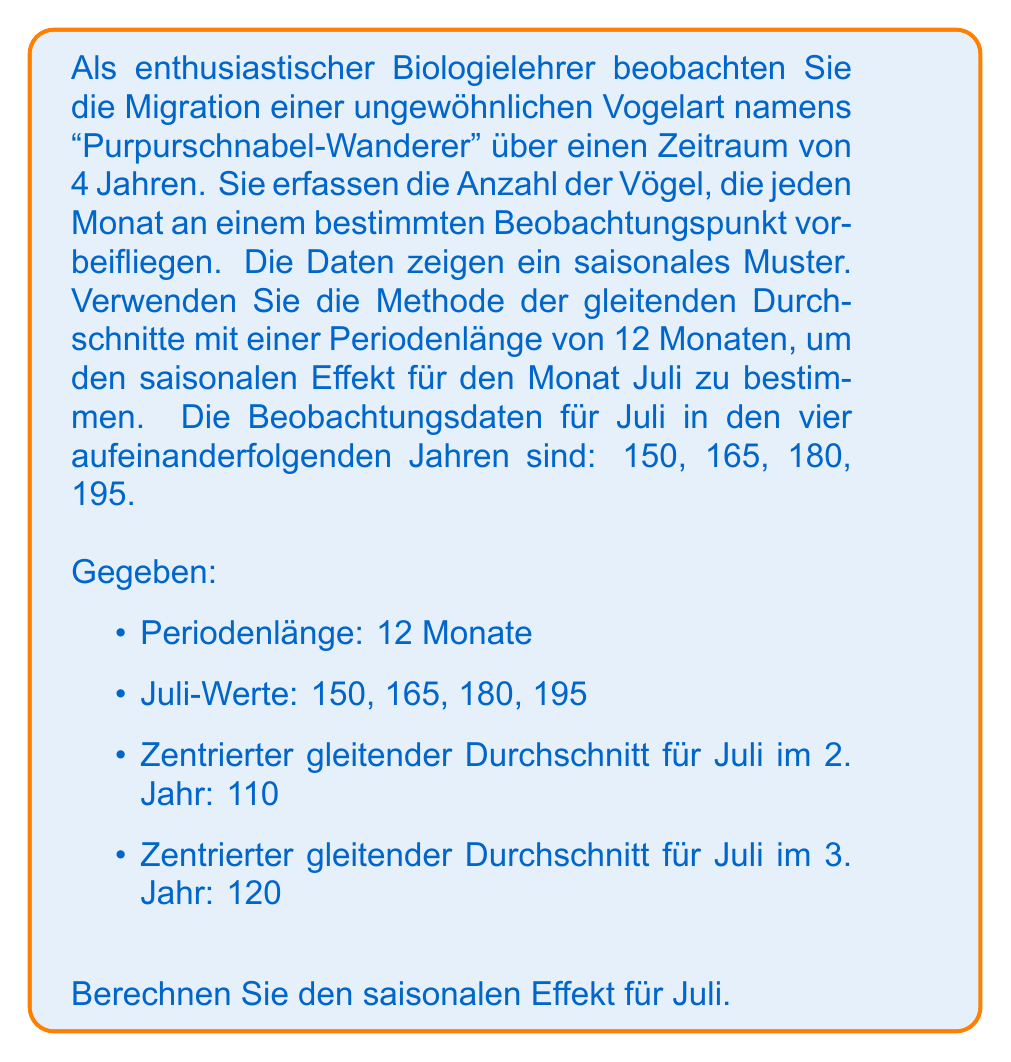Give your solution to this math problem. Um den saisonalen Effekt zu bestimmen, folgen wir diesen Schritten:

1) Berechnen der Verhältnisse zwischen den tatsächlichen Werten und den zentrierten gleitenden Durchschnitten:

Für das 2. Jahr: $\frac{165}{110} = 1.5$
Für das 3. Jahr: $\frac{180}{120} = 1.5$

2) Der Durchschnitt dieser Verhältnisse ergibt den saisonalen Faktor:

$\text{Saisonaler Faktor} = \frac{1.5 + 1.5}{2} = 1.5$

3) Um den saisonalen Effekt als Prozentsatz auszudrücken, subtrahieren wir 1 vom saisonalen Faktor und multiplizieren mit 100:

$\text{Saisonaler Effekt} = (1.5 - 1) \times 100\% = 0.5 \times 100\% = 50\%$

Dies bedeutet, dass die Anzahl der Purpurschnabel-Wanderer im Juli typischerweise 50% über dem Jahresdurchschnitt liegt.

4) Zur Überprüfung können wir die Werte für das erste und vierte Jahr betrachten:

1. Jahr: $150 \approx 100 \times 1.5$
4. Jahr: $195 \approx 130 \times 1.5$

Dies bestätigt das konsistente saisonale Muster über die Jahre hinweg.
Answer: Der saisonale Effekt für Juli beträgt $50\%$. 